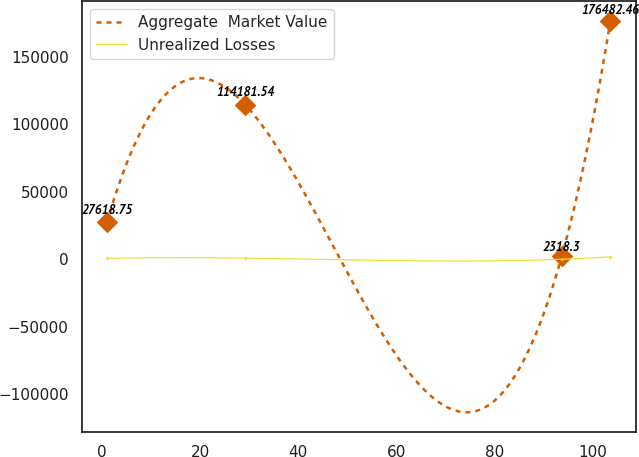Convert chart. <chart><loc_0><loc_0><loc_500><loc_500><line_chart><ecel><fcel>Aggregate  Market Value<fcel>Unrealized Losses<nl><fcel>1.06<fcel>27618.8<fcel>685.86<nl><fcel>29.23<fcel>114182<fcel>863.35<nl><fcel>93.63<fcel>2318.3<fcel>20.55<nl><fcel>103.53<fcel>176482<fcel>1795.41<nl></chart> 